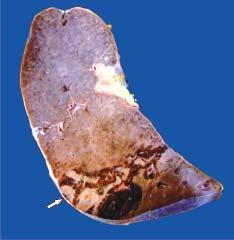what is a wedge-shaped shrunken area of pale colour seen with?
Answer the question using a single word or phrase. Base resting under the capsule 